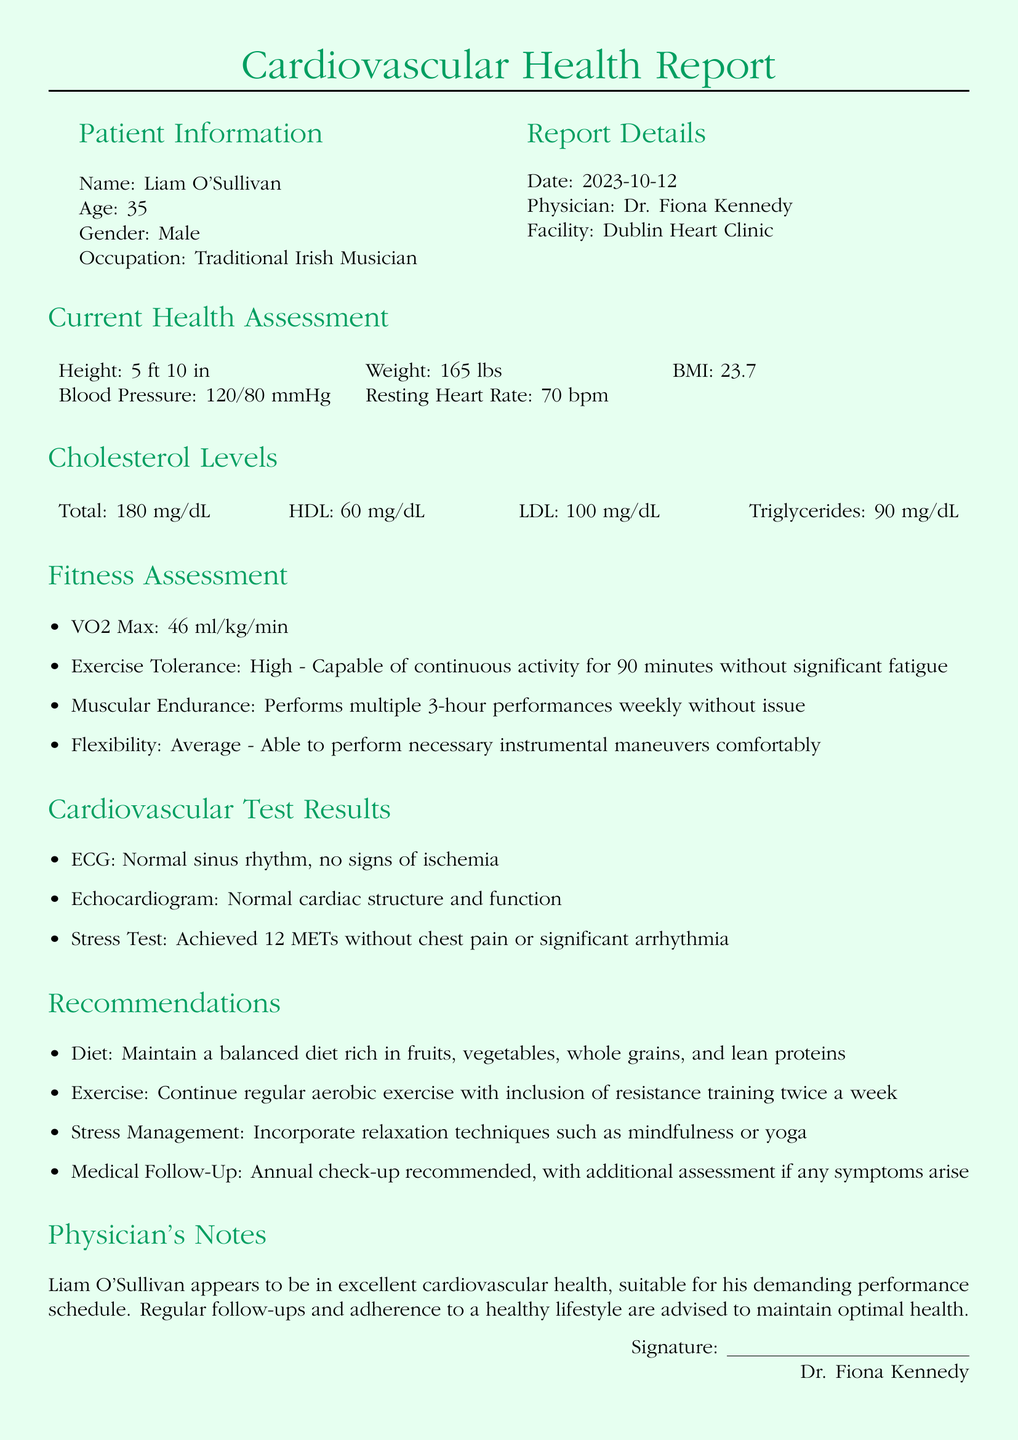What is the patient's name? The patient's name is provided in the Patient Information section of the document.
Answer: Liam O'Sullivan What is the patient's age? The patient's age is listed in the Patient Information section.
Answer: 35 What is the patient's BMI? The patient's BMI is given in the Current Health Assessment section.
Answer: 23.7 What was the date of the report? The date of the report is indicated in the Report Details section.
Answer: 2023-10-12 What is the patient's VO2 Max? The VO2 Max value is found in the Fitness Assessment section.
Answer: 46 ml/kg/min How many METs did the patient achieve in the stress test? The METs achieved in the stress test are mentioned in the Cardiovascular Test Results section.
Answer: 12 METs What is the recommended frequency for medical follow-up? The recommended frequency for follow-up is specified in the Recommendations section.
Answer: Annual What is the patient's occupation? The patient's occupation is provided in the Patient Information section of the document.
Answer: Traditional Irish Musician What type of exercise is recommended twice a week? The specific type of exercise mentioned in the Recommendations section is.
Answer: Resistance training 